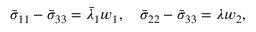Convert formula to latex. <formula><loc_0><loc_0><loc_500><loc_500>\begin{array} { r } { \bar { \sigma } _ { 1 1 } - \bar { \sigma } _ { 3 3 } = \bar { \lambda } _ { 1 } w _ { 1 } , \quad \bar { \sigma } _ { 2 2 } - \bar { \sigma } _ { 3 3 } = { \lambda } w _ { 2 } , } \end{array}</formula> 